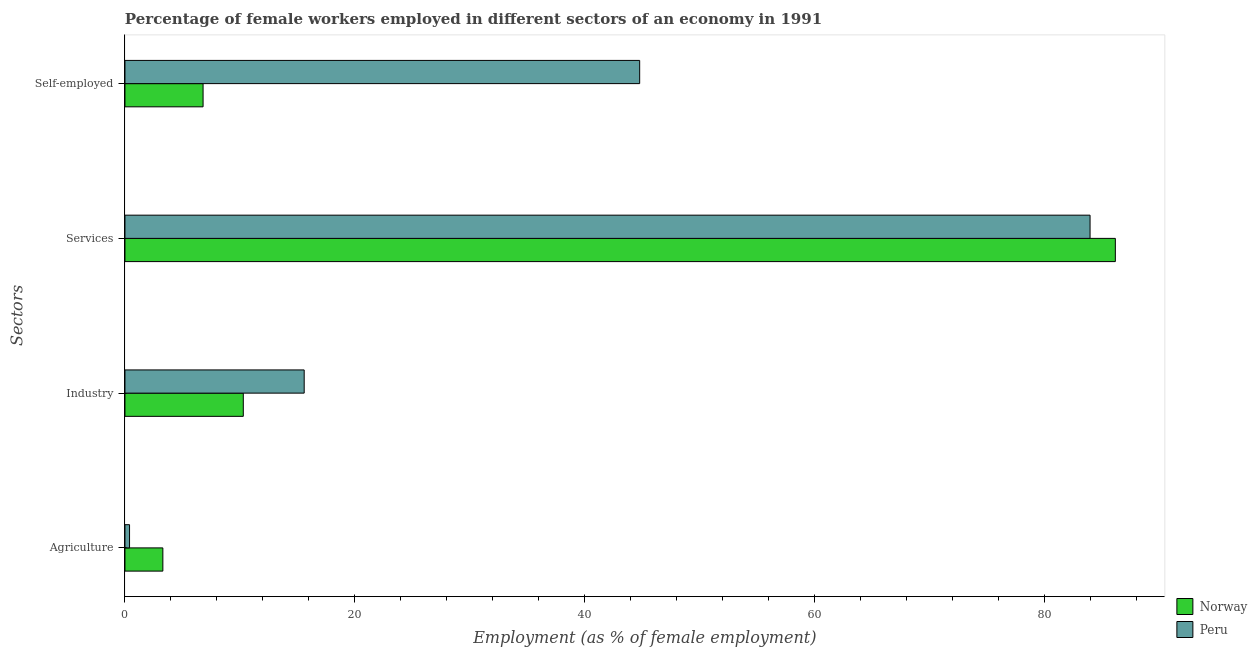How many groups of bars are there?
Offer a very short reply. 4. Are the number of bars per tick equal to the number of legend labels?
Offer a very short reply. Yes. Are the number of bars on each tick of the Y-axis equal?
Your answer should be very brief. Yes. How many bars are there on the 4th tick from the top?
Keep it short and to the point. 2. What is the label of the 4th group of bars from the top?
Your response must be concise. Agriculture. What is the percentage of female workers in industry in Norway?
Offer a terse response. 10.3. Across all countries, what is the maximum percentage of female workers in services?
Ensure brevity in your answer.  86.2. Across all countries, what is the minimum percentage of female workers in services?
Provide a short and direct response. 84. In which country was the percentage of self employed female workers maximum?
Provide a short and direct response. Peru. In which country was the percentage of female workers in agriculture minimum?
Your response must be concise. Peru. What is the total percentage of female workers in services in the graph?
Make the answer very short. 170.2. What is the difference between the percentage of female workers in services in Norway and that in Peru?
Provide a short and direct response. 2.2. What is the difference between the percentage of female workers in industry in Peru and the percentage of female workers in agriculture in Norway?
Provide a succinct answer. 12.3. What is the average percentage of female workers in services per country?
Offer a terse response. 85.1. What is the difference between the percentage of female workers in services and percentage of female workers in industry in Norway?
Keep it short and to the point. 75.9. What is the ratio of the percentage of female workers in industry in Norway to that in Peru?
Offer a very short reply. 0.66. Is the percentage of female workers in agriculture in Peru less than that in Norway?
Make the answer very short. Yes. Is the difference between the percentage of self employed female workers in Peru and Norway greater than the difference between the percentage of female workers in industry in Peru and Norway?
Offer a terse response. Yes. What is the difference between the highest and the second highest percentage of self employed female workers?
Offer a very short reply. 38. What is the difference between the highest and the lowest percentage of self employed female workers?
Provide a short and direct response. 38. Is the sum of the percentage of female workers in agriculture in Norway and Peru greater than the maximum percentage of female workers in services across all countries?
Your response must be concise. No. What does the 2nd bar from the top in Services represents?
Keep it short and to the point. Norway. How many bars are there?
Make the answer very short. 8. Are all the bars in the graph horizontal?
Make the answer very short. Yes. Does the graph contain any zero values?
Provide a short and direct response. No. Does the graph contain grids?
Your response must be concise. No. How many legend labels are there?
Offer a very short reply. 2. How are the legend labels stacked?
Offer a terse response. Vertical. What is the title of the graph?
Offer a very short reply. Percentage of female workers employed in different sectors of an economy in 1991. Does "Cabo Verde" appear as one of the legend labels in the graph?
Offer a terse response. No. What is the label or title of the X-axis?
Make the answer very short. Employment (as % of female employment). What is the label or title of the Y-axis?
Keep it short and to the point. Sectors. What is the Employment (as % of female employment) of Norway in Agriculture?
Provide a short and direct response. 3.3. What is the Employment (as % of female employment) in Peru in Agriculture?
Give a very brief answer. 0.4. What is the Employment (as % of female employment) of Norway in Industry?
Provide a succinct answer. 10.3. What is the Employment (as % of female employment) in Peru in Industry?
Your answer should be compact. 15.6. What is the Employment (as % of female employment) of Norway in Services?
Keep it short and to the point. 86.2. What is the Employment (as % of female employment) in Peru in Services?
Offer a terse response. 84. What is the Employment (as % of female employment) in Norway in Self-employed?
Provide a short and direct response. 6.8. What is the Employment (as % of female employment) of Peru in Self-employed?
Give a very brief answer. 44.8. Across all Sectors, what is the maximum Employment (as % of female employment) of Norway?
Give a very brief answer. 86.2. Across all Sectors, what is the maximum Employment (as % of female employment) of Peru?
Provide a succinct answer. 84. Across all Sectors, what is the minimum Employment (as % of female employment) in Norway?
Provide a short and direct response. 3.3. Across all Sectors, what is the minimum Employment (as % of female employment) of Peru?
Your answer should be compact. 0.4. What is the total Employment (as % of female employment) of Norway in the graph?
Your response must be concise. 106.6. What is the total Employment (as % of female employment) of Peru in the graph?
Provide a succinct answer. 144.8. What is the difference between the Employment (as % of female employment) in Norway in Agriculture and that in Industry?
Your answer should be compact. -7. What is the difference between the Employment (as % of female employment) of Peru in Agriculture and that in Industry?
Give a very brief answer. -15.2. What is the difference between the Employment (as % of female employment) in Norway in Agriculture and that in Services?
Make the answer very short. -82.9. What is the difference between the Employment (as % of female employment) of Peru in Agriculture and that in Services?
Keep it short and to the point. -83.6. What is the difference between the Employment (as % of female employment) of Norway in Agriculture and that in Self-employed?
Provide a succinct answer. -3.5. What is the difference between the Employment (as % of female employment) in Peru in Agriculture and that in Self-employed?
Provide a short and direct response. -44.4. What is the difference between the Employment (as % of female employment) in Norway in Industry and that in Services?
Your answer should be compact. -75.9. What is the difference between the Employment (as % of female employment) of Peru in Industry and that in Services?
Your answer should be very brief. -68.4. What is the difference between the Employment (as % of female employment) in Norway in Industry and that in Self-employed?
Your answer should be compact. 3.5. What is the difference between the Employment (as % of female employment) of Peru in Industry and that in Self-employed?
Your response must be concise. -29.2. What is the difference between the Employment (as % of female employment) of Norway in Services and that in Self-employed?
Your response must be concise. 79.4. What is the difference between the Employment (as % of female employment) of Peru in Services and that in Self-employed?
Keep it short and to the point. 39.2. What is the difference between the Employment (as % of female employment) of Norway in Agriculture and the Employment (as % of female employment) of Peru in Industry?
Give a very brief answer. -12.3. What is the difference between the Employment (as % of female employment) of Norway in Agriculture and the Employment (as % of female employment) of Peru in Services?
Provide a succinct answer. -80.7. What is the difference between the Employment (as % of female employment) in Norway in Agriculture and the Employment (as % of female employment) in Peru in Self-employed?
Provide a short and direct response. -41.5. What is the difference between the Employment (as % of female employment) in Norway in Industry and the Employment (as % of female employment) in Peru in Services?
Provide a short and direct response. -73.7. What is the difference between the Employment (as % of female employment) of Norway in Industry and the Employment (as % of female employment) of Peru in Self-employed?
Give a very brief answer. -34.5. What is the difference between the Employment (as % of female employment) in Norway in Services and the Employment (as % of female employment) in Peru in Self-employed?
Offer a very short reply. 41.4. What is the average Employment (as % of female employment) in Norway per Sectors?
Ensure brevity in your answer.  26.65. What is the average Employment (as % of female employment) in Peru per Sectors?
Ensure brevity in your answer.  36.2. What is the difference between the Employment (as % of female employment) of Norway and Employment (as % of female employment) of Peru in Agriculture?
Ensure brevity in your answer.  2.9. What is the difference between the Employment (as % of female employment) in Norway and Employment (as % of female employment) in Peru in Industry?
Your answer should be compact. -5.3. What is the difference between the Employment (as % of female employment) of Norway and Employment (as % of female employment) of Peru in Self-employed?
Offer a very short reply. -38. What is the ratio of the Employment (as % of female employment) of Norway in Agriculture to that in Industry?
Make the answer very short. 0.32. What is the ratio of the Employment (as % of female employment) of Peru in Agriculture to that in Industry?
Your response must be concise. 0.03. What is the ratio of the Employment (as % of female employment) in Norway in Agriculture to that in Services?
Ensure brevity in your answer.  0.04. What is the ratio of the Employment (as % of female employment) in Peru in Agriculture to that in Services?
Provide a short and direct response. 0. What is the ratio of the Employment (as % of female employment) of Norway in Agriculture to that in Self-employed?
Your answer should be very brief. 0.49. What is the ratio of the Employment (as % of female employment) of Peru in Agriculture to that in Self-employed?
Give a very brief answer. 0.01. What is the ratio of the Employment (as % of female employment) of Norway in Industry to that in Services?
Make the answer very short. 0.12. What is the ratio of the Employment (as % of female employment) in Peru in Industry to that in Services?
Make the answer very short. 0.19. What is the ratio of the Employment (as % of female employment) of Norway in Industry to that in Self-employed?
Give a very brief answer. 1.51. What is the ratio of the Employment (as % of female employment) in Peru in Industry to that in Self-employed?
Your answer should be compact. 0.35. What is the ratio of the Employment (as % of female employment) in Norway in Services to that in Self-employed?
Ensure brevity in your answer.  12.68. What is the ratio of the Employment (as % of female employment) of Peru in Services to that in Self-employed?
Keep it short and to the point. 1.88. What is the difference between the highest and the second highest Employment (as % of female employment) of Norway?
Keep it short and to the point. 75.9. What is the difference between the highest and the second highest Employment (as % of female employment) of Peru?
Offer a very short reply. 39.2. What is the difference between the highest and the lowest Employment (as % of female employment) in Norway?
Keep it short and to the point. 82.9. What is the difference between the highest and the lowest Employment (as % of female employment) of Peru?
Provide a succinct answer. 83.6. 